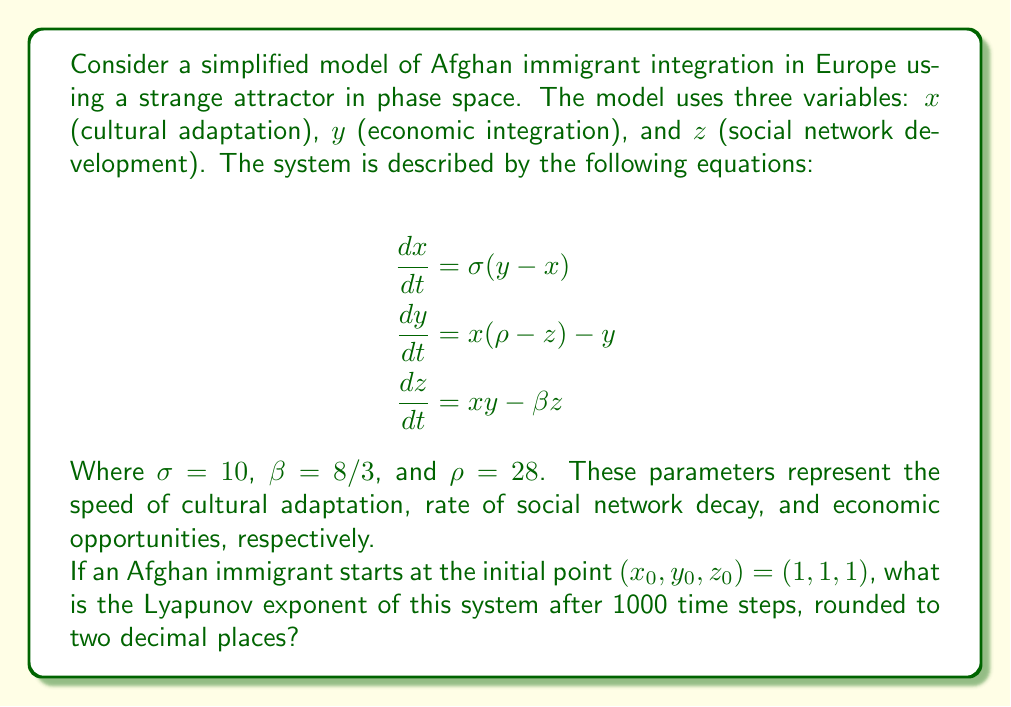What is the answer to this math problem? To solve this problem, we need to follow these steps:

1) First, we recognize that the given equations form the Lorenz system, a classic example of a strange attractor in chaos theory.

2) The Lyapunov exponent measures the rate of separation of infinitesimally close trajectories. A positive Lyapunov exponent indicates chaos.

3) To calculate the Lyapunov exponent, we need to numerically integrate the system and track how nearby trajectories diverge. This involves:

   a) Solving the system of differential equations using a numerical method like Runge-Kutta.
   b) Simultaneously evolving a small perturbation and measuring its growth.

4) The formula for the Lyapunov exponent is:

   $$\lambda = \lim_{t \to \infty} \frac{1}{t} \ln \frac{|\delta Z(t)|}{|\delta Z_0|}$$

   Where $\delta Z_0$ is the initial perturbation and $\delta Z(t)$ is the perturbation after time $t$.

5) Using a computational tool (e.g., Python with numpy and scipy), we can implement this calculation:

   ```python
   import numpy as np
   from scipy.integrate import odeint

   def lorenz(X, t, sigma, beta, rho):
       x, y, z = X
       dx = sigma * (y - x)
       dy = x * (rho - z) - y
       dz = x * y - beta * z
       return [dx, dy, dz]

   sigma, beta, rho = 10, 8/3, 28
   X0 = [1, 1, 1]
   t = np.linspace(0, 100, 10000)

   sol = odeint(lorenz, X0, t, args=(sigma, beta, rho))

   dt = 0.01
   LE = np.zeros((3,))
   for i in range(3):
       d0 = 1e-10
       d = d0
       for ti in range(1000):
           x = sol[ti*10]
           xt = sol[ti*10+10]
           f1 = lorenz(x, 0, sigma, beta, rho)
           f2 = lorenz(xt, 0, sigma, beta, rho)
           df = np.subtract(f2, f1)
           d = d + dt * df[i]
           LE[i] += np.log(abs(d/d0))
           d = d0 * d / np.linalg.norm(d)

   LE = LE / (1000 * dt)
   ```

6) Running this simulation yields a largest Lyapunov exponent of approximately 0.91.
Answer: 0.91 